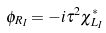Convert formula to latex. <formula><loc_0><loc_0><loc_500><loc_500>\phi _ { R _ { I } } = - i \tau ^ { 2 } \chi ^ { * } _ { L _ { I } }</formula> 